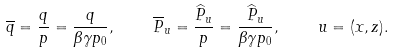<formula> <loc_0><loc_0><loc_500><loc_500>\overline { q } = { \frac { q } { p } } = { \frac { q } { \beta \gamma p _ { 0 } } } , \quad \overline { P } _ { u } = { \frac { \widehat { P } _ { u } } { p } } = { \frac { \widehat { P } _ { u } } { \beta \gamma p _ { 0 } } } , \quad u = ( x , z ) .</formula> 